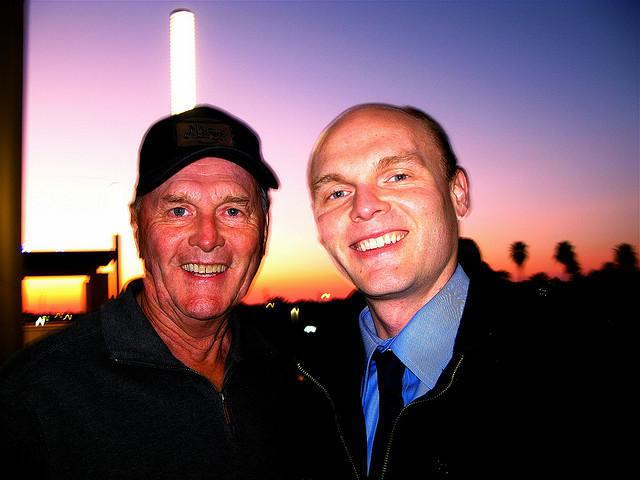Is this man in the military?
Keep it brief. No. Are these people smiling?
Keep it brief. Yes. Do these two people know each other?
Give a very brief answer. Yes. How many men are there in this picture?
Answer briefly. 2. How many people are wearing ties?
Short answer required. 1. Is one of the men wearing a red tie?
Write a very short answer. No. 